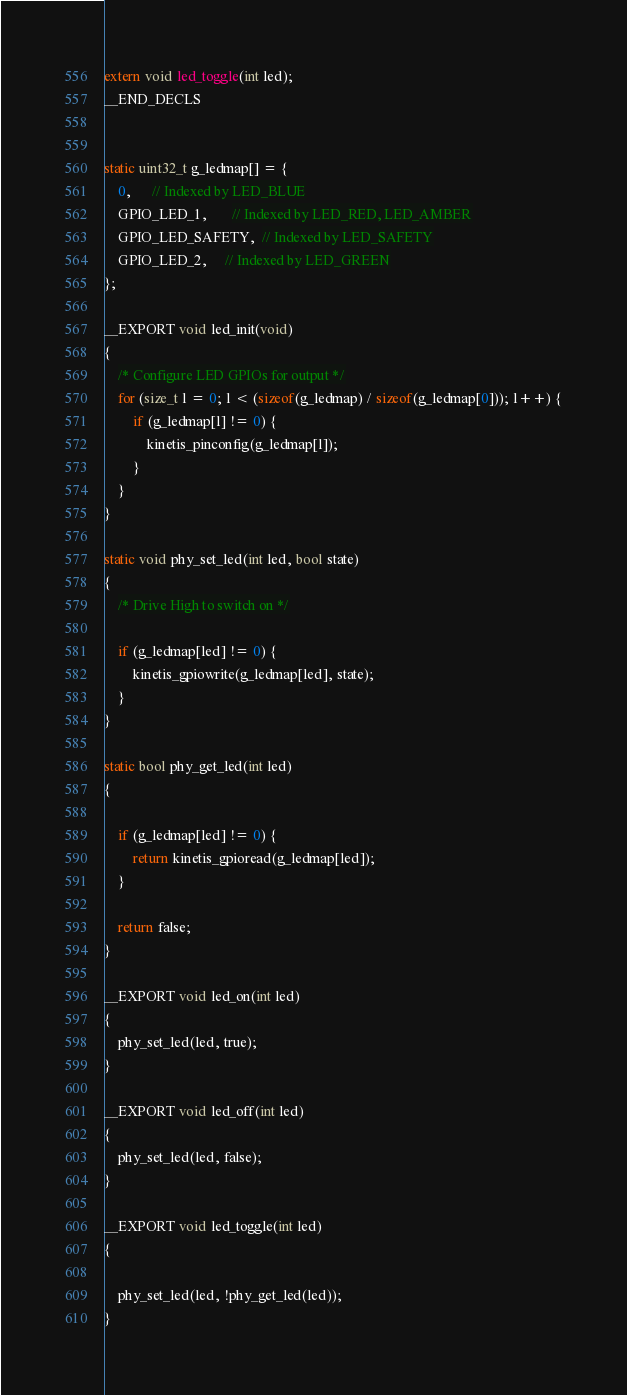<code> <loc_0><loc_0><loc_500><loc_500><_C_>extern void led_toggle(int led);
__END_DECLS


static uint32_t g_ledmap[] = {
	0,      // Indexed by LED_BLUE
	GPIO_LED_1,       // Indexed by LED_RED, LED_AMBER
	GPIO_LED_SAFETY,  // Indexed by LED_SAFETY
	GPIO_LED_2,     // Indexed by LED_GREEN
};

__EXPORT void led_init(void)
{
	/* Configure LED GPIOs for output */
	for (size_t l = 0; l < (sizeof(g_ledmap) / sizeof(g_ledmap[0])); l++) {
		if (g_ledmap[l] != 0) {
			kinetis_pinconfig(g_ledmap[l]);
		}
	}
}

static void phy_set_led(int led, bool state)
{
	/* Drive High to switch on */

	if (g_ledmap[led] != 0) {
		kinetis_gpiowrite(g_ledmap[led], state);
	}
}

static bool phy_get_led(int led)
{

	if (g_ledmap[led] != 0) {
		return kinetis_gpioread(g_ledmap[led]);
	}

	return false;
}

__EXPORT void led_on(int led)
{
	phy_set_led(led, true);
}

__EXPORT void led_off(int led)
{
	phy_set_led(led, false);
}

__EXPORT void led_toggle(int led)
{

	phy_set_led(led, !phy_get_led(led));
}
</code> 